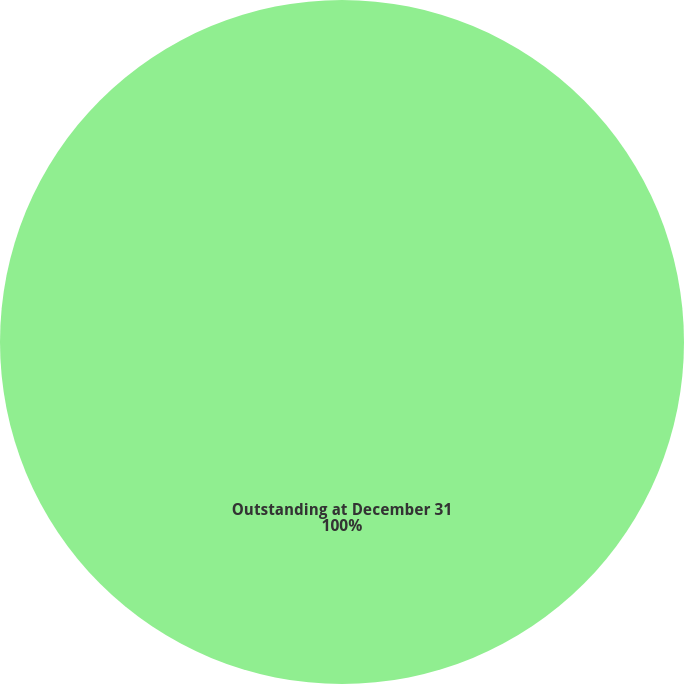<chart> <loc_0><loc_0><loc_500><loc_500><pie_chart><fcel>Outstanding at December 31<nl><fcel>100.0%<nl></chart> 